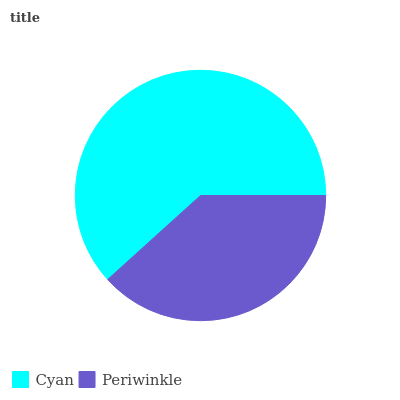Is Periwinkle the minimum?
Answer yes or no. Yes. Is Cyan the maximum?
Answer yes or no. Yes. Is Periwinkle the maximum?
Answer yes or no. No. Is Cyan greater than Periwinkle?
Answer yes or no. Yes. Is Periwinkle less than Cyan?
Answer yes or no. Yes. Is Periwinkle greater than Cyan?
Answer yes or no. No. Is Cyan less than Periwinkle?
Answer yes or no. No. Is Cyan the high median?
Answer yes or no. Yes. Is Periwinkle the low median?
Answer yes or no. Yes. Is Periwinkle the high median?
Answer yes or no. No. Is Cyan the low median?
Answer yes or no. No. 